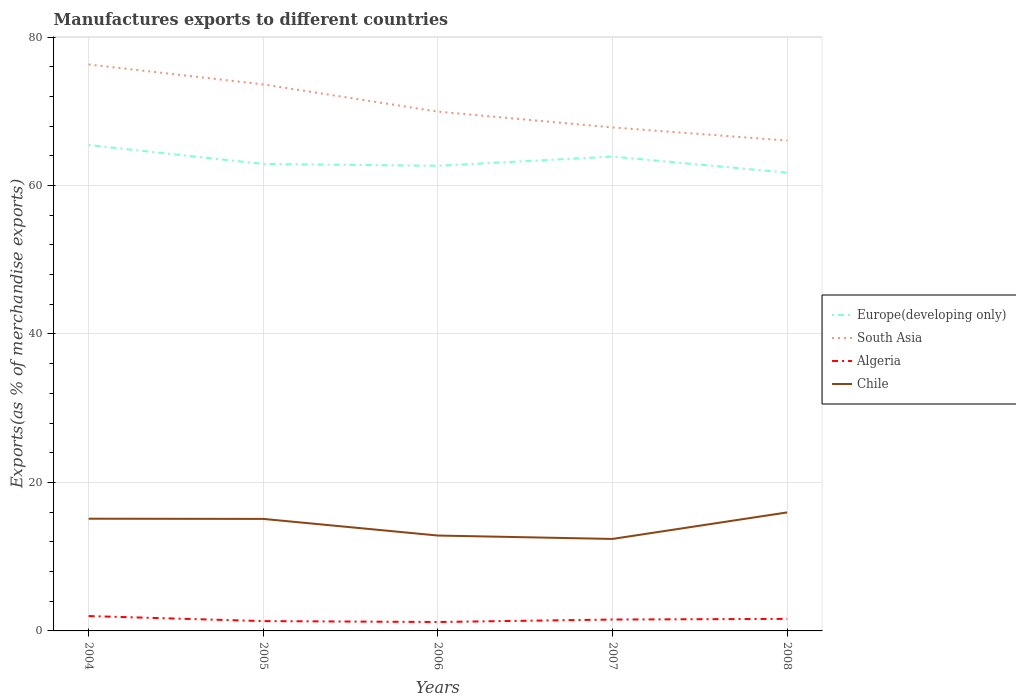How many different coloured lines are there?
Your answer should be compact. 4. Does the line corresponding to South Asia intersect with the line corresponding to Algeria?
Your answer should be very brief. No. Is the number of lines equal to the number of legend labels?
Ensure brevity in your answer.  Yes. Across all years, what is the maximum percentage of exports to different countries in Europe(developing only)?
Your response must be concise. 61.74. What is the total percentage of exports to different countries in Algeria in the graph?
Give a very brief answer. -0.33. What is the difference between the highest and the second highest percentage of exports to different countries in Algeria?
Provide a short and direct response. 0.8. What is the difference between two consecutive major ticks on the Y-axis?
Your answer should be very brief. 20. Does the graph contain any zero values?
Provide a succinct answer. No. Does the graph contain grids?
Give a very brief answer. Yes. What is the title of the graph?
Provide a succinct answer. Manufactures exports to different countries. What is the label or title of the Y-axis?
Give a very brief answer. Exports(as % of merchandise exports). What is the Exports(as % of merchandise exports) in Europe(developing only) in 2004?
Ensure brevity in your answer.  65.46. What is the Exports(as % of merchandise exports) of South Asia in 2004?
Keep it short and to the point. 76.31. What is the Exports(as % of merchandise exports) of Algeria in 2004?
Give a very brief answer. 2. What is the Exports(as % of merchandise exports) of Chile in 2004?
Provide a succinct answer. 15.12. What is the Exports(as % of merchandise exports) in Europe(developing only) in 2005?
Your response must be concise. 62.91. What is the Exports(as % of merchandise exports) in South Asia in 2005?
Provide a succinct answer. 73.62. What is the Exports(as % of merchandise exports) in Algeria in 2005?
Offer a very short reply. 1.32. What is the Exports(as % of merchandise exports) in Chile in 2005?
Ensure brevity in your answer.  15.09. What is the Exports(as % of merchandise exports) of Europe(developing only) in 2006?
Give a very brief answer. 62.66. What is the Exports(as % of merchandise exports) of South Asia in 2006?
Offer a very short reply. 69.96. What is the Exports(as % of merchandise exports) of Algeria in 2006?
Offer a terse response. 1.2. What is the Exports(as % of merchandise exports) in Chile in 2006?
Your answer should be compact. 12.85. What is the Exports(as % of merchandise exports) of Europe(developing only) in 2007?
Keep it short and to the point. 63.9. What is the Exports(as % of merchandise exports) of South Asia in 2007?
Make the answer very short. 67.83. What is the Exports(as % of merchandise exports) in Algeria in 2007?
Provide a short and direct response. 1.53. What is the Exports(as % of merchandise exports) of Chile in 2007?
Make the answer very short. 12.39. What is the Exports(as % of merchandise exports) in Europe(developing only) in 2008?
Offer a very short reply. 61.74. What is the Exports(as % of merchandise exports) in South Asia in 2008?
Give a very brief answer. 66.06. What is the Exports(as % of merchandise exports) in Algeria in 2008?
Keep it short and to the point. 1.62. What is the Exports(as % of merchandise exports) of Chile in 2008?
Provide a succinct answer. 15.96. Across all years, what is the maximum Exports(as % of merchandise exports) in Europe(developing only)?
Make the answer very short. 65.46. Across all years, what is the maximum Exports(as % of merchandise exports) in South Asia?
Give a very brief answer. 76.31. Across all years, what is the maximum Exports(as % of merchandise exports) of Algeria?
Provide a short and direct response. 2. Across all years, what is the maximum Exports(as % of merchandise exports) in Chile?
Your answer should be very brief. 15.96. Across all years, what is the minimum Exports(as % of merchandise exports) of Europe(developing only)?
Offer a terse response. 61.74. Across all years, what is the minimum Exports(as % of merchandise exports) of South Asia?
Your answer should be very brief. 66.06. Across all years, what is the minimum Exports(as % of merchandise exports) in Algeria?
Give a very brief answer. 1.2. Across all years, what is the minimum Exports(as % of merchandise exports) in Chile?
Keep it short and to the point. 12.39. What is the total Exports(as % of merchandise exports) in Europe(developing only) in the graph?
Provide a short and direct response. 316.67. What is the total Exports(as % of merchandise exports) in South Asia in the graph?
Offer a terse response. 353.78. What is the total Exports(as % of merchandise exports) in Algeria in the graph?
Make the answer very short. 7.68. What is the total Exports(as % of merchandise exports) of Chile in the graph?
Give a very brief answer. 71.42. What is the difference between the Exports(as % of merchandise exports) of Europe(developing only) in 2004 and that in 2005?
Keep it short and to the point. 2.54. What is the difference between the Exports(as % of merchandise exports) in South Asia in 2004 and that in 2005?
Give a very brief answer. 2.69. What is the difference between the Exports(as % of merchandise exports) of Algeria in 2004 and that in 2005?
Make the answer very short. 0.68. What is the difference between the Exports(as % of merchandise exports) of Chile in 2004 and that in 2005?
Provide a succinct answer. 0.03. What is the difference between the Exports(as % of merchandise exports) in Europe(developing only) in 2004 and that in 2006?
Your answer should be compact. 2.79. What is the difference between the Exports(as % of merchandise exports) of South Asia in 2004 and that in 2006?
Your answer should be very brief. 6.35. What is the difference between the Exports(as % of merchandise exports) in Algeria in 2004 and that in 2006?
Offer a very short reply. 0.8. What is the difference between the Exports(as % of merchandise exports) in Chile in 2004 and that in 2006?
Your answer should be compact. 2.27. What is the difference between the Exports(as % of merchandise exports) of Europe(developing only) in 2004 and that in 2007?
Offer a very short reply. 1.55. What is the difference between the Exports(as % of merchandise exports) in South Asia in 2004 and that in 2007?
Keep it short and to the point. 8.49. What is the difference between the Exports(as % of merchandise exports) of Algeria in 2004 and that in 2007?
Provide a succinct answer. 0.47. What is the difference between the Exports(as % of merchandise exports) in Chile in 2004 and that in 2007?
Your answer should be very brief. 2.73. What is the difference between the Exports(as % of merchandise exports) in Europe(developing only) in 2004 and that in 2008?
Offer a terse response. 3.72. What is the difference between the Exports(as % of merchandise exports) of South Asia in 2004 and that in 2008?
Your answer should be very brief. 10.25. What is the difference between the Exports(as % of merchandise exports) of Algeria in 2004 and that in 2008?
Make the answer very short. 0.38. What is the difference between the Exports(as % of merchandise exports) of Chile in 2004 and that in 2008?
Offer a terse response. -0.85. What is the difference between the Exports(as % of merchandise exports) in Europe(developing only) in 2005 and that in 2006?
Give a very brief answer. 0.25. What is the difference between the Exports(as % of merchandise exports) of South Asia in 2005 and that in 2006?
Provide a succinct answer. 3.66. What is the difference between the Exports(as % of merchandise exports) in Algeria in 2005 and that in 2006?
Keep it short and to the point. 0.12. What is the difference between the Exports(as % of merchandise exports) in Chile in 2005 and that in 2006?
Your response must be concise. 2.24. What is the difference between the Exports(as % of merchandise exports) in Europe(developing only) in 2005 and that in 2007?
Your response must be concise. -0.99. What is the difference between the Exports(as % of merchandise exports) in South Asia in 2005 and that in 2007?
Give a very brief answer. 5.8. What is the difference between the Exports(as % of merchandise exports) of Algeria in 2005 and that in 2007?
Make the answer very short. -0.21. What is the difference between the Exports(as % of merchandise exports) of Chile in 2005 and that in 2007?
Ensure brevity in your answer.  2.7. What is the difference between the Exports(as % of merchandise exports) in Europe(developing only) in 2005 and that in 2008?
Ensure brevity in your answer.  1.17. What is the difference between the Exports(as % of merchandise exports) of South Asia in 2005 and that in 2008?
Ensure brevity in your answer.  7.56. What is the difference between the Exports(as % of merchandise exports) in Algeria in 2005 and that in 2008?
Keep it short and to the point. -0.3. What is the difference between the Exports(as % of merchandise exports) of Chile in 2005 and that in 2008?
Give a very brief answer. -0.87. What is the difference between the Exports(as % of merchandise exports) in Europe(developing only) in 2006 and that in 2007?
Your answer should be very brief. -1.24. What is the difference between the Exports(as % of merchandise exports) in South Asia in 2006 and that in 2007?
Give a very brief answer. 2.13. What is the difference between the Exports(as % of merchandise exports) of Algeria in 2006 and that in 2007?
Keep it short and to the point. -0.33. What is the difference between the Exports(as % of merchandise exports) of Chile in 2006 and that in 2007?
Ensure brevity in your answer.  0.46. What is the difference between the Exports(as % of merchandise exports) in Europe(developing only) in 2006 and that in 2008?
Your response must be concise. 0.92. What is the difference between the Exports(as % of merchandise exports) in South Asia in 2006 and that in 2008?
Give a very brief answer. 3.9. What is the difference between the Exports(as % of merchandise exports) of Algeria in 2006 and that in 2008?
Provide a short and direct response. -0.42. What is the difference between the Exports(as % of merchandise exports) of Chile in 2006 and that in 2008?
Your response must be concise. -3.12. What is the difference between the Exports(as % of merchandise exports) in Europe(developing only) in 2007 and that in 2008?
Your answer should be compact. 2.16. What is the difference between the Exports(as % of merchandise exports) in South Asia in 2007 and that in 2008?
Ensure brevity in your answer.  1.77. What is the difference between the Exports(as % of merchandise exports) in Algeria in 2007 and that in 2008?
Offer a very short reply. -0.09. What is the difference between the Exports(as % of merchandise exports) in Chile in 2007 and that in 2008?
Make the answer very short. -3.57. What is the difference between the Exports(as % of merchandise exports) of Europe(developing only) in 2004 and the Exports(as % of merchandise exports) of South Asia in 2005?
Offer a terse response. -8.17. What is the difference between the Exports(as % of merchandise exports) of Europe(developing only) in 2004 and the Exports(as % of merchandise exports) of Algeria in 2005?
Your answer should be very brief. 64.13. What is the difference between the Exports(as % of merchandise exports) in Europe(developing only) in 2004 and the Exports(as % of merchandise exports) in Chile in 2005?
Your answer should be very brief. 50.37. What is the difference between the Exports(as % of merchandise exports) in South Asia in 2004 and the Exports(as % of merchandise exports) in Algeria in 2005?
Provide a short and direct response. 74.99. What is the difference between the Exports(as % of merchandise exports) in South Asia in 2004 and the Exports(as % of merchandise exports) in Chile in 2005?
Offer a terse response. 61.22. What is the difference between the Exports(as % of merchandise exports) of Algeria in 2004 and the Exports(as % of merchandise exports) of Chile in 2005?
Provide a short and direct response. -13.09. What is the difference between the Exports(as % of merchandise exports) in Europe(developing only) in 2004 and the Exports(as % of merchandise exports) in South Asia in 2006?
Your response must be concise. -4.5. What is the difference between the Exports(as % of merchandise exports) in Europe(developing only) in 2004 and the Exports(as % of merchandise exports) in Algeria in 2006?
Offer a terse response. 64.25. What is the difference between the Exports(as % of merchandise exports) of Europe(developing only) in 2004 and the Exports(as % of merchandise exports) of Chile in 2006?
Provide a short and direct response. 52.61. What is the difference between the Exports(as % of merchandise exports) of South Asia in 2004 and the Exports(as % of merchandise exports) of Algeria in 2006?
Make the answer very short. 75.11. What is the difference between the Exports(as % of merchandise exports) in South Asia in 2004 and the Exports(as % of merchandise exports) in Chile in 2006?
Ensure brevity in your answer.  63.46. What is the difference between the Exports(as % of merchandise exports) in Algeria in 2004 and the Exports(as % of merchandise exports) in Chile in 2006?
Your answer should be very brief. -10.85. What is the difference between the Exports(as % of merchandise exports) in Europe(developing only) in 2004 and the Exports(as % of merchandise exports) in South Asia in 2007?
Give a very brief answer. -2.37. What is the difference between the Exports(as % of merchandise exports) in Europe(developing only) in 2004 and the Exports(as % of merchandise exports) in Algeria in 2007?
Your answer should be compact. 63.92. What is the difference between the Exports(as % of merchandise exports) of Europe(developing only) in 2004 and the Exports(as % of merchandise exports) of Chile in 2007?
Ensure brevity in your answer.  53.06. What is the difference between the Exports(as % of merchandise exports) of South Asia in 2004 and the Exports(as % of merchandise exports) of Algeria in 2007?
Give a very brief answer. 74.78. What is the difference between the Exports(as % of merchandise exports) of South Asia in 2004 and the Exports(as % of merchandise exports) of Chile in 2007?
Keep it short and to the point. 63.92. What is the difference between the Exports(as % of merchandise exports) in Algeria in 2004 and the Exports(as % of merchandise exports) in Chile in 2007?
Make the answer very short. -10.39. What is the difference between the Exports(as % of merchandise exports) in Europe(developing only) in 2004 and the Exports(as % of merchandise exports) in South Asia in 2008?
Give a very brief answer. -0.6. What is the difference between the Exports(as % of merchandise exports) in Europe(developing only) in 2004 and the Exports(as % of merchandise exports) in Algeria in 2008?
Provide a short and direct response. 63.83. What is the difference between the Exports(as % of merchandise exports) in Europe(developing only) in 2004 and the Exports(as % of merchandise exports) in Chile in 2008?
Provide a short and direct response. 49.49. What is the difference between the Exports(as % of merchandise exports) in South Asia in 2004 and the Exports(as % of merchandise exports) in Algeria in 2008?
Your response must be concise. 74.69. What is the difference between the Exports(as % of merchandise exports) of South Asia in 2004 and the Exports(as % of merchandise exports) of Chile in 2008?
Keep it short and to the point. 60.35. What is the difference between the Exports(as % of merchandise exports) of Algeria in 2004 and the Exports(as % of merchandise exports) of Chile in 2008?
Your response must be concise. -13.96. What is the difference between the Exports(as % of merchandise exports) of Europe(developing only) in 2005 and the Exports(as % of merchandise exports) of South Asia in 2006?
Provide a succinct answer. -7.05. What is the difference between the Exports(as % of merchandise exports) in Europe(developing only) in 2005 and the Exports(as % of merchandise exports) in Algeria in 2006?
Offer a very short reply. 61.71. What is the difference between the Exports(as % of merchandise exports) of Europe(developing only) in 2005 and the Exports(as % of merchandise exports) of Chile in 2006?
Keep it short and to the point. 50.06. What is the difference between the Exports(as % of merchandise exports) of South Asia in 2005 and the Exports(as % of merchandise exports) of Algeria in 2006?
Make the answer very short. 72.42. What is the difference between the Exports(as % of merchandise exports) of South Asia in 2005 and the Exports(as % of merchandise exports) of Chile in 2006?
Keep it short and to the point. 60.77. What is the difference between the Exports(as % of merchandise exports) of Algeria in 2005 and the Exports(as % of merchandise exports) of Chile in 2006?
Give a very brief answer. -11.53. What is the difference between the Exports(as % of merchandise exports) of Europe(developing only) in 2005 and the Exports(as % of merchandise exports) of South Asia in 2007?
Make the answer very short. -4.91. What is the difference between the Exports(as % of merchandise exports) of Europe(developing only) in 2005 and the Exports(as % of merchandise exports) of Algeria in 2007?
Keep it short and to the point. 61.38. What is the difference between the Exports(as % of merchandise exports) in Europe(developing only) in 2005 and the Exports(as % of merchandise exports) in Chile in 2007?
Your answer should be compact. 50.52. What is the difference between the Exports(as % of merchandise exports) in South Asia in 2005 and the Exports(as % of merchandise exports) in Algeria in 2007?
Provide a succinct answer. 72.09. What is the difference between the Exports(as % of merchandise exports) in South Asia in 2005 and the Exports(as % of merchandise exports) in Chile in 2007?
Offer a terse response. 61.23. What is the difference between the Exports(as % of merchandise exports) in Algeria in 2005 and the Exports(as % of merchandise exports) in Chile in 2007?
Give a very brief answer. -11.07. What is the difference between the Exports(as % of merchandise exports) in Europe(developing only) in 2005 and the Exports(as % of merchandise exports) in South Asia in 2008?
Make the answer very short. -3.15. What is the difference between the Exports(as % of merchandise exports) in Europe(developing only) in 2005 and the Exports(as % of merchandise exports) in Algeria in 2008?
Offer a very short reply. 61.29. What is the difference between the Exports(as % of merchandise exports) in Europe(developing only) in 2005 and the Exports(as % of merchandise exports) in Chile in 2008?
Your answer should be compact. 46.95. What is the difference between the Exports(as % of merchandise exports) in South Asia in 2005 and the Exports(as % of merchandise exports) in Algeria in 2008?
Keep it short and to the point. 72. What is the difference between the Exports(as % of merchandise exports) in South Asia in 2005 and the Exports(as % of merchandise exports) in Chile in 2008?
Make the answer very short. 57.66. What is the difference between the Exports(as % of merchandise exports) of Algeria in 2005 and the Exports(as % of merchandise exports) of Chile in 2008?
Keep it short and to the point. -14.64. What is the difference between the Exports(as % of merchandise exports) in Europe(developing only) in 2006 and the Exports(as % of merchandise exports) in South Asia in 2007?
Offer a very short reply. -5.16. What is the difference between the Exports(as % of merchandise exports) of Europe(developing only) in 2006 and the Exports(as % of merchandise exports) of Algeria in 2007?
Keep it short and to the point. 61.13. What is the difference between the Exports(as % of merchandise exports) of Europe(developing only) in 2006 and the Exports(as % of merchandise exports) of Chile in 2007?
Your response must be concise. 50.27. What is the difference between the Exports(as % of merchandise exports) in South Asia in 2006 and the Exports(as % of merchandise exports) in Algeria in 2007?
Your response must be concise. 68.42. What is the difference between the Exports(as % of merchandise exports) in South Asia in 2006 and the Exports(as % of merchandise exports) in Chile in 2007?
Offer a very short reply. 57.57. What is the difference between the Exports(as % of merchandise exports) in Algeria in 2006 and the Exports(as % of merchandise exports) in Chile in 2007?
Make the answer very short. -11.19. What is the difference between the Exports(as % of merchandise exports) of Europe(developing only) in 2006 and the Exports(as % of merchandise exports) of South Asia in 2008?
Make the answer very short. -3.4. What is the difference between the Exports(as % of merchandise exports) in Europe(developing only) in 2006 and the Exports(as % of merchandise exports) in Algeria in 2008?
Provide a short and direct response. 61.04. What is the difference between the Exports(as % of merchandise exports) of Europe(developing only) in 2006 and the Exports(as % of merchandise exports) of Chile in 2008?
Your answer should be compact. 46.7. What is the difference between the Exports(as % of merchandise exports) in South Asia in 2006 and the Exports(as % of merchandise exports) in Algeria in 2008?
Make the answer very short. 68.34. What is the difference between the Exports(as % of merchandise exports) in South Asia in 2006 and the Exports(as % of merchandise exports) in Chile in 2008?
Keep it short and to the point. 53.99. What is the difference between the Exports(as % of merchandise exports) of Algeria in 2006 and the Exports(as % of merchandise exports) of Chile in 2008?
Your response must be concise. -14.76. What is the difference between the Exports(as % of merchandise exports) in Europe(developing only) in 2007 and the Exports(as % of merchandise exports) in South Asia in 2008?
Ensure brevity in your answer.  -2.16. What is the difference between the Exports(as % of merchandise exports) of Europe(developing only) in 2007 and the Exports(as % of merchandise exports) of Algeria in 2008?
Provide a short and direct response. 62.28. What is the difference between the Exports(as % of merchandise exports) in Europe(developing only) in 2007 and the Exports(as % of merchandise exports) in Chile in 2008?
Your answer should be very brief. 47.94. What is the difference between the Exports(as % of merchandise exports) of South Asia in 2007 and the Exports(as % of merchandise exports) of Algeria in 2008?
Offer a terse response. 66.2. What is the difference between the Exports(as % of merchandise exports) in South Asia in 2007 and the Exports(as % of merchandise exports) in Chile in 2008?
Provide a succinct answer. 51.86. What is the difference between the Exports(as % of merchandise exports) of Algeria in 2007 and the Exports(as % of merchandise exports) of Chile in 2008?
Your answer should be compact. -14.43. What is the average Exports(as % of merchandise exports) in Europe(developing only) per year?
Offer a very short reply. 63.33. What is the average Exports(as % of merchandise exports) in South Asia per year?
Keep it short and to the point. 70.76. What is the average Exports(as % of merchandise exports) in Algeria per year?
Offer a very short reply. 1.54. What is the average Exports(as % of merchandise exports) of Chile per year?
Offer a terse response. 14.28. In the year 2004, what is the difference between the Exports(as % of merchandise exports) of Europe(developing only) and Exports(as % of merchandise exports) of South Asia?
Your response must be concise. -10.86. In the year 2004, what is the difference between the Exports(as % of merchandise exports) of Europe(developing only) and Exports(as % of merchandise exports) of Algeria?
Your answer should be very brief. 63.45. In the year 2004, what is the difference between the Exports(as % of merchandise exports) of Europe(developing only) and Exports(as % of merchandise exports) of Chile?
Provide a short and direct response. 50.34. In the year 2004, what is the difference between the Exports(as % of merchandise exports) of South Asia and Exports(as % of merchandise exports) of Algeria?
Provide a succinct answer. 74.31. In the year 2004, what is the difference between the Exports(as % of merchandise exports) in South Asia and Exports(as % of merchandise exports) in Chile?
Provide a short and direct response. 61.19. In the year 2004, what is the difference between the Exports(as % of merchandise exports) in Algeria and Exports(as % of merchandise exports) in Chile?
Keep it short and to the point. -13.12. In the year 2005, what is the difference between the Exports(as % of merchandise exports) of Europe(developing only) and Exports(as % of merchandise exports) of South Asia?
Your response must be concise. -10.71. In the year 2005, what is the difference between the Exports(as % of merchandise exports) of Europe(developing only) and Exports(as % of merchandise exports) of Algeria?
Your answer should be very brief. 61.59. In the year 2005, what is the difference between the Exports(as % of merchandise exports) of Europe(developing only) and Exports(as % of merchandise exports) of Chile?
Provide a succinct answer. 47.82. In the year 2005, what is the difference between the Exports(as % of merchandise exports) of South Asia and Exports(as % of merchandise exports) of Algeria?
Offer a terse response. 72.3. In the year 2005, what is the difference between the Exports(as % of merchandise exports) of South Asia and Exports(as % of merchandise exports) of Chile?
Your answer should be compact. 58.53. In the year 2005, what is the difference between the Exports(as % of merchandise exports) of Algeria and Exports(as % of merchandise exports) of Chile?
Offer a terse response. -13.77. In the year 2006, what is the difference between the Exports(as % of merchandise exports) in Europe(developing only) and Exports(as % of merchandise exports) in South Asia?
Make the answer very short. -7.3. In the year 2006, what is the difference between the Exports(as % of merchandise exports) of Europe(developing only) and Exports(as % of merchandise exports) of Algeria?
Make the answer very short. 61.46. In the year 2006, what is the difference between the Exports(as % of merchandise exports) in Europe(developing only) and Exports(as % of merchandise exports) in Chile?
Provide a succinct answer. 49.81. In the year 2006, what is the difference between the Exports(as % of merchandise exports) of South Asia and Exports(as % of merchandise exports) of Algeria?
Ensure brevity in your answer.  68.76. In the year 2006, what is the difference between the Exports(as % of merchandise exports) in South Asia and Exports(as % of merchandise exports) in Chile?
Your answer should be very brief. 57.11. In the year 2006, what is the difference between the Exports(as % of merchandise exports) of Algeria and Exports(as % of merchandise exports) of Chile?
Ensure brevity in your answer.  -11.65. In the year 2007, what is the difference between the Exports(as % of merchandise exports) in Europe(developing only) and Exports(as % of merchandise exports) in South Asia?
Give a very brief answer. -3.92. In the year 2007, what is the difference between the Exports(as % of merchandise exports) in Europe(developing only) and Exports(as % of merchandise exports) in Algeria?
Offer a terse response. 62.37. In the year 2007, what is the difference between the Exports(as % of merchandise exports) of Europe(developing only) and Exports(as % of merchandise exports) of Chile?
Provide a short and direct response. 51.51. In the year 2007, what is the difference between the Exports(as % of merchandise exports) in South Asia and Exports(as % of merchandise exports) in Algeria?
Provide a succinct answer. 66.29. In the year 2007, what is the difference between the Exports(as % of merchandise exports) in South Asia and Exports(as % of merchandise exports) in Chile?
Make the answer very short. 55.43. In the year 2007, what is the difference between the Exports(as % of merchandise exports) of Algeria and Exports(as % of merchandise exports) of Chile?
Your response must be concise. -10.86. In the year 2008, what is the difference between the Exports(as % of merchandise exports) of Europe(developing only) and Exports(as % of merchandise exports) of South Asia?
Your response must be concise. -4.32. In the year 2008, what is the difference between the Exports(as % of merchandise exports) of Europe(developing only) and Exports(as % of merchandise exports) of Algeria?
Your answer should be very brief. 60.12. In the year 2008, what is the difference between the Exports(as % of merchandise exports) in Europe(developing only) and Exports(as % of merchandise exports) in Chile?
Give a very brief answer. 45.77. In the year 2008, what is the difference between the Exports(as % of merchandise exports) of South Asia and Exports(as % of merchandise exports) of Algeria?
Offer a very short reply. 64.44. In the year 2008, what is the difference between the Exports(as % of merchandise exports) of South Asia and Exports(as % of merchandise exports) of Chile?
Provide a succinct answer. 50.1. In the year 2008, what is the difference between the Exports(as % of merchandise exports) in Algeria and Exports(as % of merchandise exports) in Chile?
Provide a short and direct response. -14.34. What is the ratio of the Exports(as % of merchandise exports) of Europe(developing only) in 2004 to that in 2005?
Provide a short and direct response. 1.04. What is the ratio of the Exports(as % of merchandise exports) of South Asia in 2004 to that in 2005?
Give a very brief answer. 1.04. What is the ratio of the Exports(as % of merchandise exports) in Algeria in 2004 to that in 2005?
Your answer should be compact. 1.51. What is the ratio of the Exports(as % of merchandise exports) of Europe(developing only) in 2004 to that in 2006?
Keep it short and to the point. 1.04. What is the ratio of the Exports(as % of merchandise exports) in South Asia in 2004 to that in 2006?
Give a very brief answer. 1.09. What is the ratio of the Exports(as % of merchandise exports) in Algeria in 2004 to that in 2006?
Give a very brief answer. 1.67. What is the ratio of the Exports(as % of merchandise exports) in Chile in 2004 to that in 2006?
Offer a very short reply. 1.18. What is the ratio of the Exports(as % of merchandise exports) of Europe(developing only) in 2004 to that in 2007?
Give a very brief answer. 1.02. What is the ratio of the Exports(as % of merchandise exports) in South Asia in 2004 to that in 2007?
Provide a short and direct response. 1.13. What is the ratio of the Exports(as % of merchandise exports) of Algeria in 2004 to that in 2007?
Your answer should be very brief. 1.31. What is the ratio of the Exports(as % of merchandise exports) of Chile in 2004 to that in 2007?
Provide a succinct answer. 1.22. What is the ratio of the Exports(as % of merchandise exports) in Europe(developing only) in 2004 to that in 2008?
Your answer should be compact. 1.06. What is the ratio of the Exports(as % of merchandise exports) of South Asia in 2004 to that in 2008?
Ensure brevity in your answer.  1.16. What is the ratio of the Exports(as % of merchandise exports) in Algeria in 2004 to that in 2008?
Keep it short and to the point. 1.24. What is the ratio of the Exports(as % of merchandise exports) in Chile in 2004 to that in 2008?
Provide a short and direct response. 0.95. What is the ratio of the Exports(as % of merchandise exports) in South Asia in 2005 to that in 2006?
Keep it short and to the point. 1.05. What is the ratio of the Exports(as % of merchandise exports) of Algeria in 2005 to that in 2006?
Your answer should be compact. 1.1. What is the ratio of the Exports(as % of merchandise exports) in Chile in 2005 to that in 2006?
Your response must be concise. 1.17. What is the ratio of the Exports(as % of merchandise exports) of Europe(developing only) in 2005 to that in 2007?
Provide a short and direct response. 0.98. What is the ratio of the Exports(as % of merchandise exports) of South Asia in 2005 to that in 2007?
Keep it short and to the point. 1.09. What is the ratio of the Exports(as % of merchandise exports) in Algeria in 2005 to that in 2007?
Keep it short and to the point. 0.86. What is the ratio of the Exports(as % of merchandise exports) of Chile in 2005 to that in 2007?
Your response must be concise. 1.22. What is the ratio of the Exports(as % of merchandise exports) of South Asia in 2005 to that in 2008?
Your answer should be very brief. 1.11. What is the ratio of the Exports(as % of merchandise exports) in Algeria in 2005 to that in 2008?
Provide a short and direct response. 0.82. What is the ratio of the Exports(as % of merchandise exports) in Chile in 2005 to that in 2008?
Give a very brief answer. 0.95. What is the ratio of the Exports(as % of merchandise exports) in Europe(developing only) in 2006 to that in 2007?
Offer a terse response. 0.98. What is the ratio of the Exports(as % of merchandise exports) of South Asia in 2006 to that in 2007?
Provide a short and direct response. 1.03. What is the ratio of the Exports(as % of merchandise exports) of Algeria in 2006 to that in 2007?
Offer a terse response. 0.78. What is the ratio of the Exports(as % of merchandise exports) of Chile in 2006 to that in 2007?
Ensure brevity in your answer.  1.04. What is the ratio of the Exports(as % of merchandise exports) of South Asia in 2006 to that in 2008?
Make the answer very short. 1.06. What is the ratio of the Exports(as % of merchandise exports) in Algeria in 2006 to that in 2008?
Offer a terse response. 0.74. What is the ratio of the Exports(as % of merchandise exports) in Chile in 2006 to that in 2008?
Offer a terse response. 0.8. What is the ratio of the Exports(as % of merchandise exports) in Europe(developing only) in 2007 to that in 2008?
Make the answer very short. 1.04. What is the ratio of the Exports(as % of merchandise exports) in South Asia in 2007 to that in 2008?
Ensure brevity in your answer.  1.03. What is the ratio of the Exports(as % of merchandise exports) of Algeria in 2007 to that in 2008?
Ensure brevity in your answer.  0.95. What is the ratio of the Exports(as % of merchandise exports) of Chile in 2007 to that in 2008?
Keep it short and to the point. 0.78. What is the difference between the highest and the second highest Exports(as % of merchandise exports) of Europe(developing only)?
Give a very brief answer. 1.55. What is the difference between the highest and the second highest Exports(as % of merchandise exports) in South Asia?
Make the answer very short. 2.69. What is the difference between the highest and the second highest Exports(as % of merchandise exports) in Algeria?
Keep it short and to the point. 0.38. What is the difference between the highest and the second highest Exports(as % of merchandise exports) of Chile?
Your answer should be very brief. 0.85. What is the difference between the highest and the lowest Exports(as % of merchandise exports) in Europe(developing only)?
Your answer should be very brief. 3.72. What is the difference between the highest and the lowest Exports(as % of merchandise exports) in South Asia?
Provide a succinct answer. 10.25. What is the difference between the highest and the lowest Exports(as % of merchandise exports) in Algeria?
Your response must be concise. 0.8. What is the difference between the highest and the lowest Exports(as % of merchandise exports) in Chile?
Give a very brief answer. 3.57. 